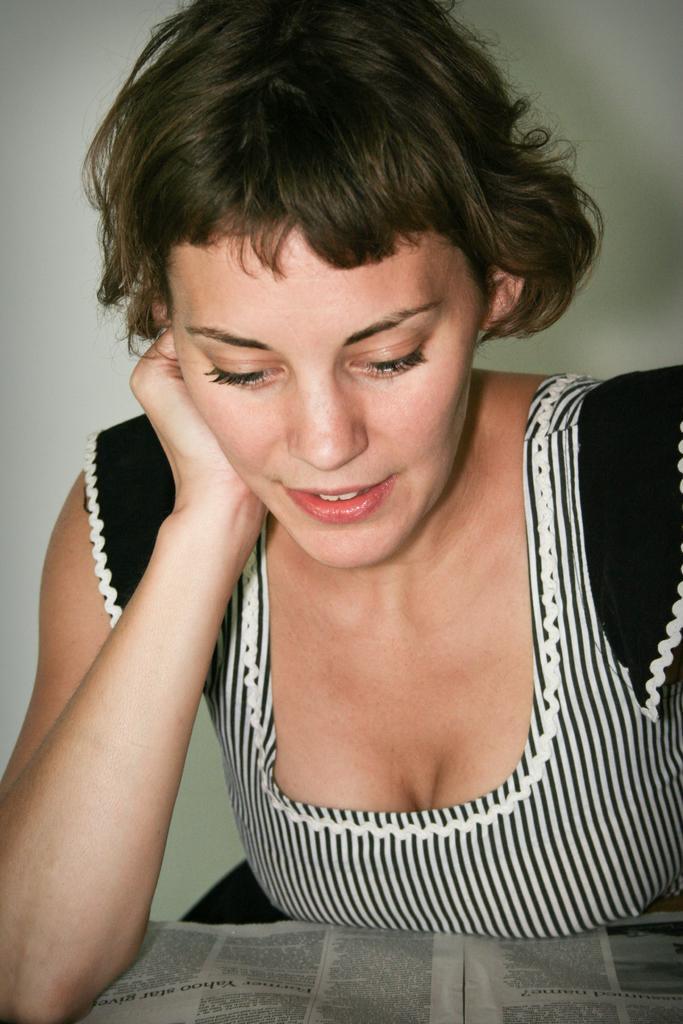Can you describe this image briefly? In this image we can see a woman reading newspaper on the table. 